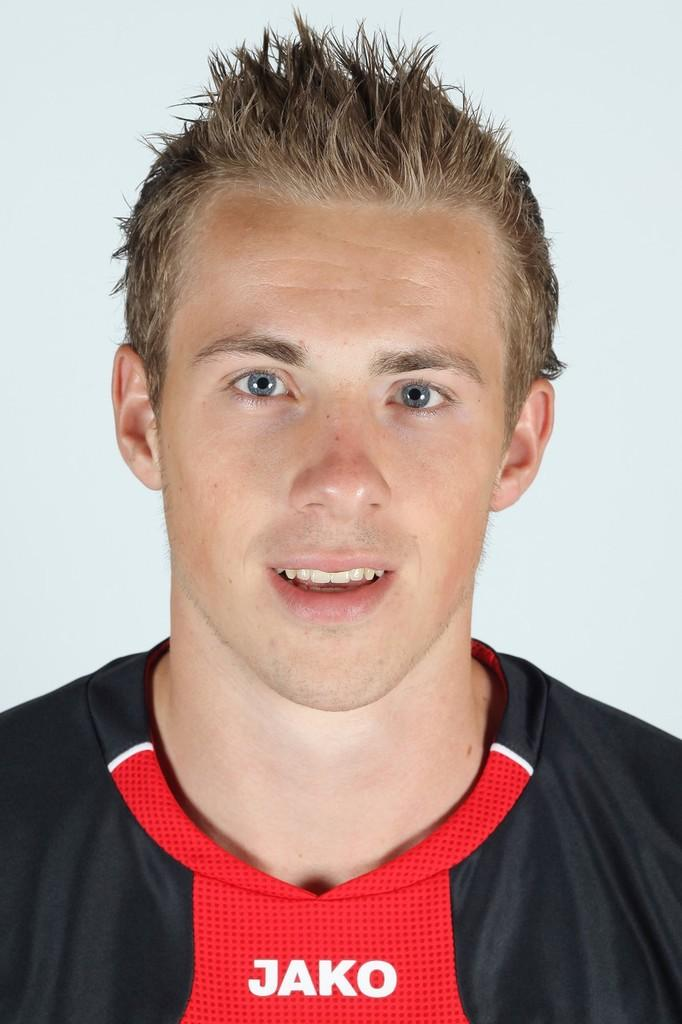<image>
Write a terse but informative summary of the picture. A boy is wearing a shirt with JAKO written on the front of it. 